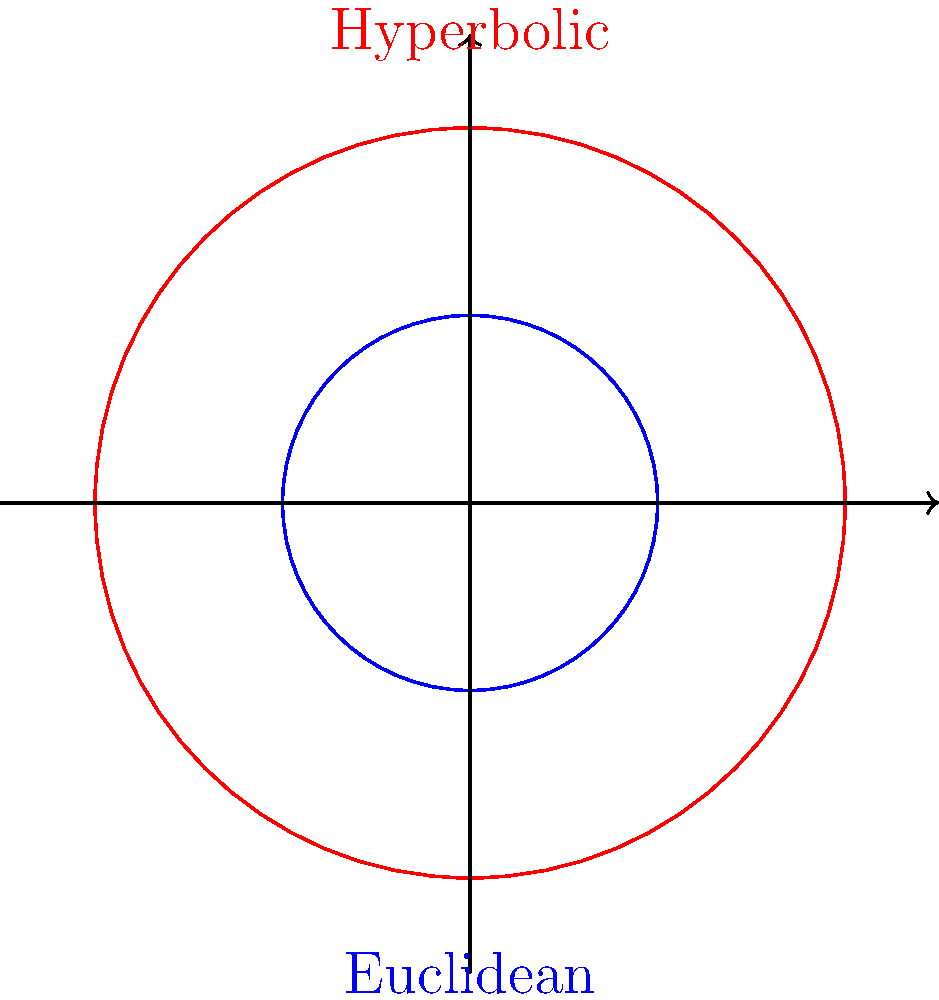As a digital archivist recommending cultural sites, you encounter a unique architectural feature inspired by non-Euclidean geometry. The diagram shows two circles: one in Euclidean geometry (blue) and one in hyperbolic geometry (red). If the radius of the red circle is twice that of the blue circle, how does the area of the red circle compare to the area of the blue circle in hyperbolic geometry? To understand this comparison, let's follow these steps:

1) In Euclidean geometry:
   - Area of a circle: $A = \pi r^2$
   - If we double the radius, the area increases by a factor of 4

2) In hyperbolic geometry:
   - Area of a circle: $A = 4\pi \sinh^2(\frac{r}{2})$
   - Where $\sinh$ is the hyperbolic sine function

3) Let's compare the areas:
   - For the blue circle (radius $r$): $A_1 = 4\pi \sinh^2(\frac{r}{2})$
   - For the red circle (radius $2r$): $A_2 = 4\pi \sinh^2(r)$

4) Key property of hyperbolic sine:
   $\sinh(2x) = 2\sinh(x)\cosh(x)$

5) Using this property:
   $\sinh^2(r) = (\frac{\sinh(2r)}{2})^2 = \frac{\sinh^2(2r)}{4} > \sinh^2(\frac{r}{2})$

6) Therefore:
   $A_2 = 4\pi \sinh^2(r) > 4\pi \sinh^2(\frac{r}{2}) = A_1$

7) However, the increase is less than four times, unlike in Euclidean geometry

This unexpected geometric behavior could inspire unique architectural designs in cultural sites, showcasing the interplay between mathematics and cultural heritage.
Answer: The area increases, but less than four times. 